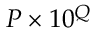<formula> <loc_0><loc_0><loc_500><loc_500>P \times 1 0 ^ { Q }</formula> 